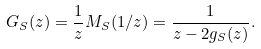<formula> <loc_0><loc_0><loc_500><loc_500>G _ { S } ( z ) = \frac { 1 } { z } M _ { S } ( 1 / z ) = \frac { 1 } { z - 2 g _ { S } ( z ) } .</formula> 